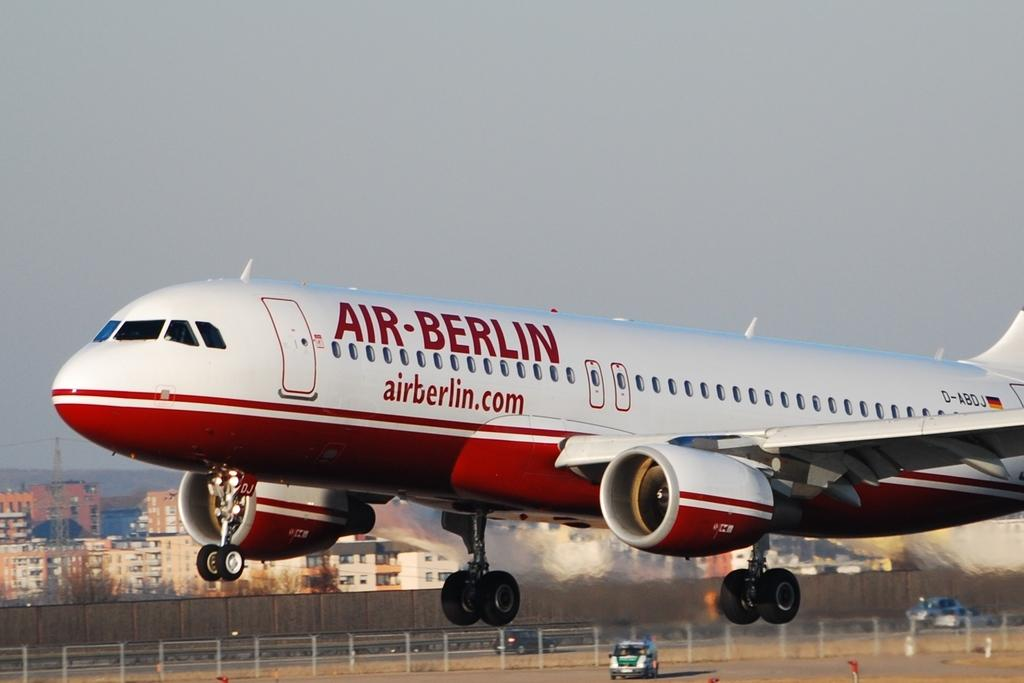<image>
Write a terse but informative summary of the picture. An Air-Berlin plane advertises the website airberlin.com and is in the process of either taking off or landing. 